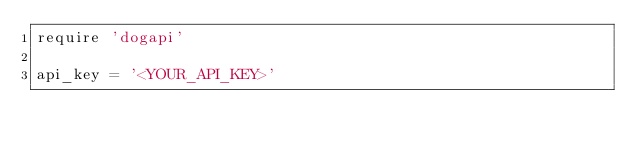Convert code to text. <code><loc_0><loc_0><loc_500><loc_500><_Ruby_>require 'dogapi'

api_key = '<YOUR_API_KEY>'</code> 